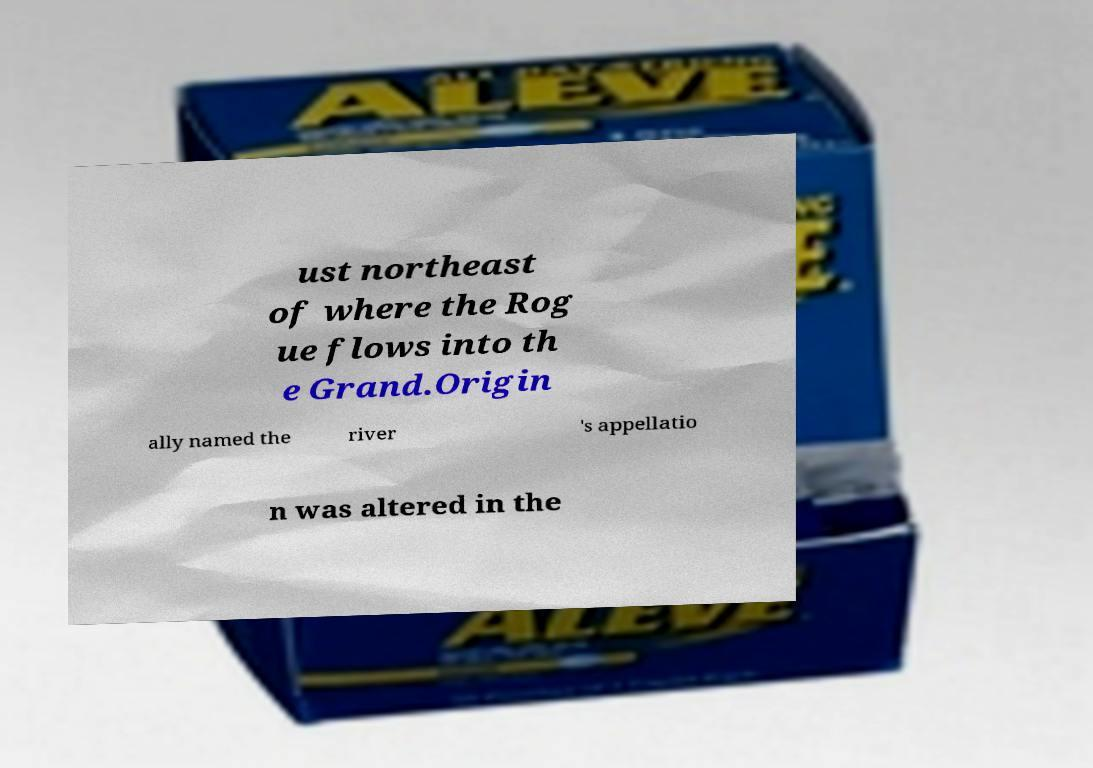Please identify and transcribe the text found in this image. ust northeast of where the Rog ue flows into th e Grand.Origin ally named the river 's appellatio n was altered in the 